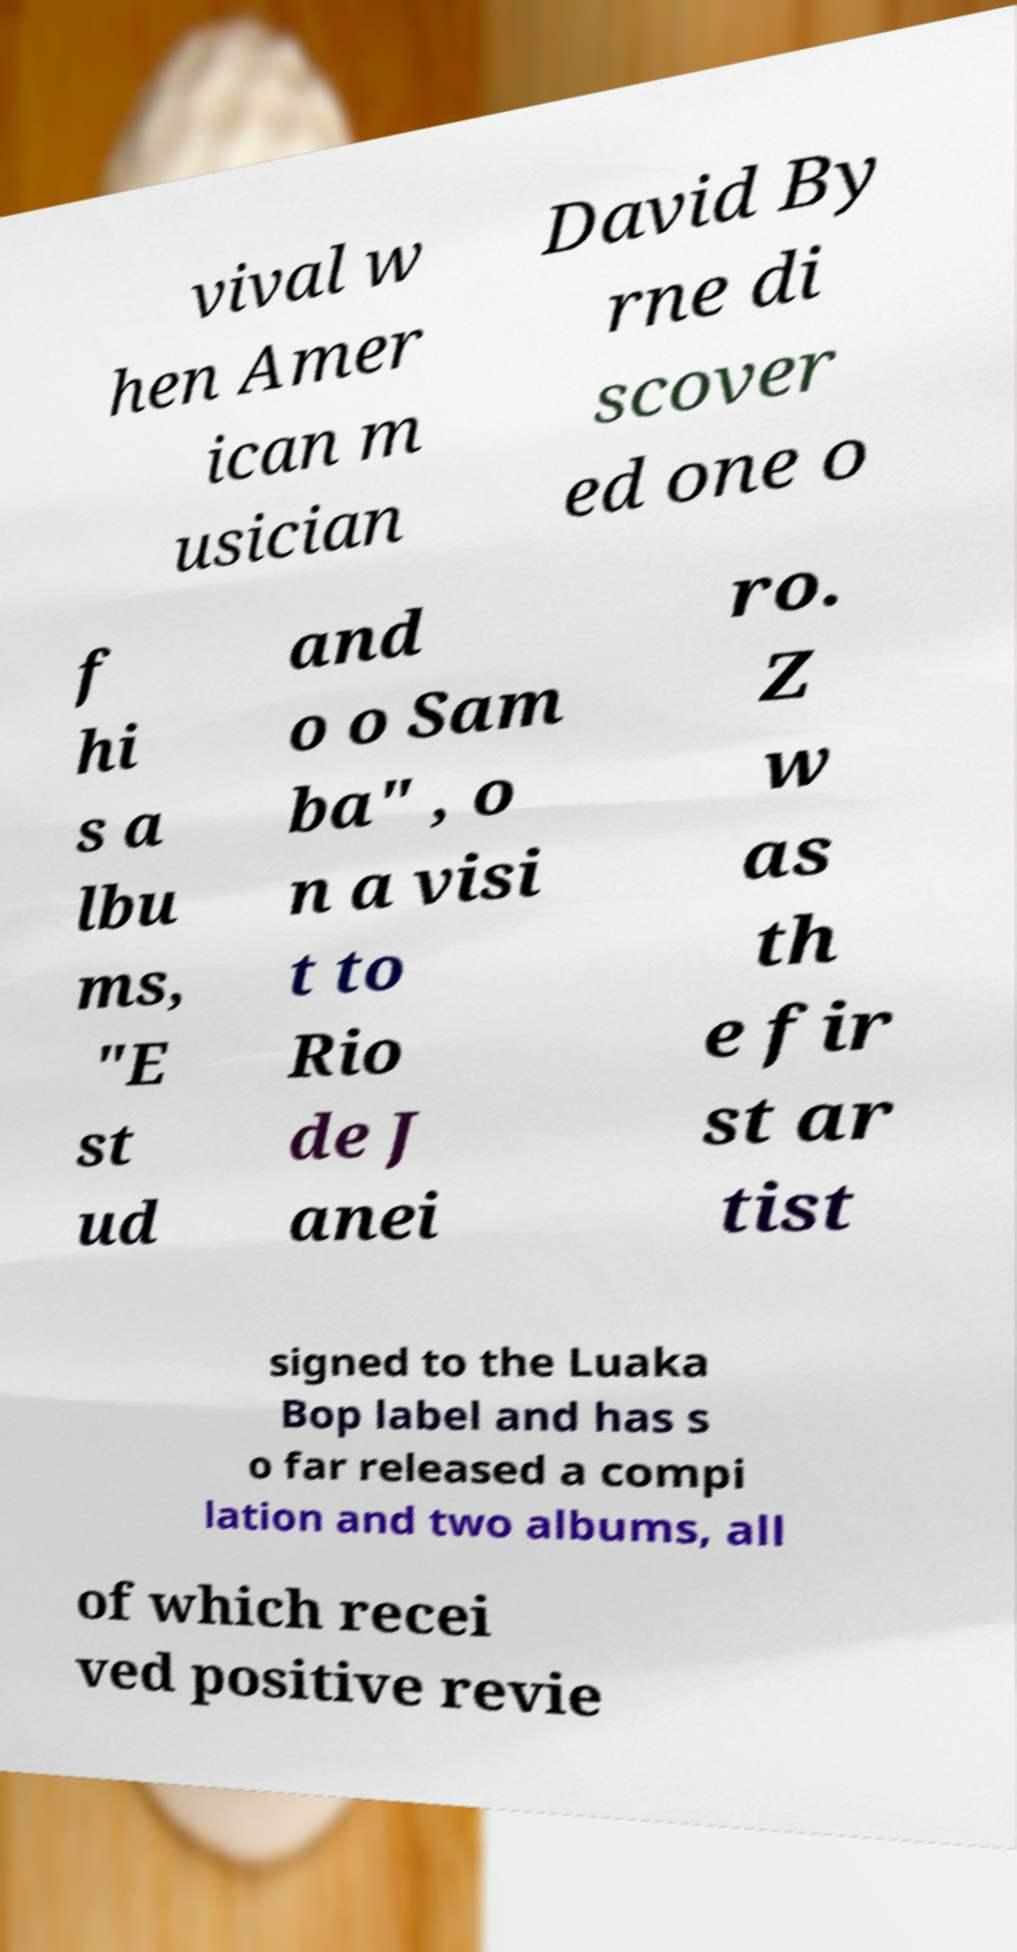Can you accurately transcribe the text from the provided image for me? vival w hen Amer ican m usician David By rne di scover ed one o f hi s a lbu ms, "E st ud and o o Sam ba" , o n a visi t to Rio de J anei ro. Z w as th e fir st ar tist signed to the Luaka Bop label and has s o far released a compi lation and two albums, all of which recei ved positive revie 